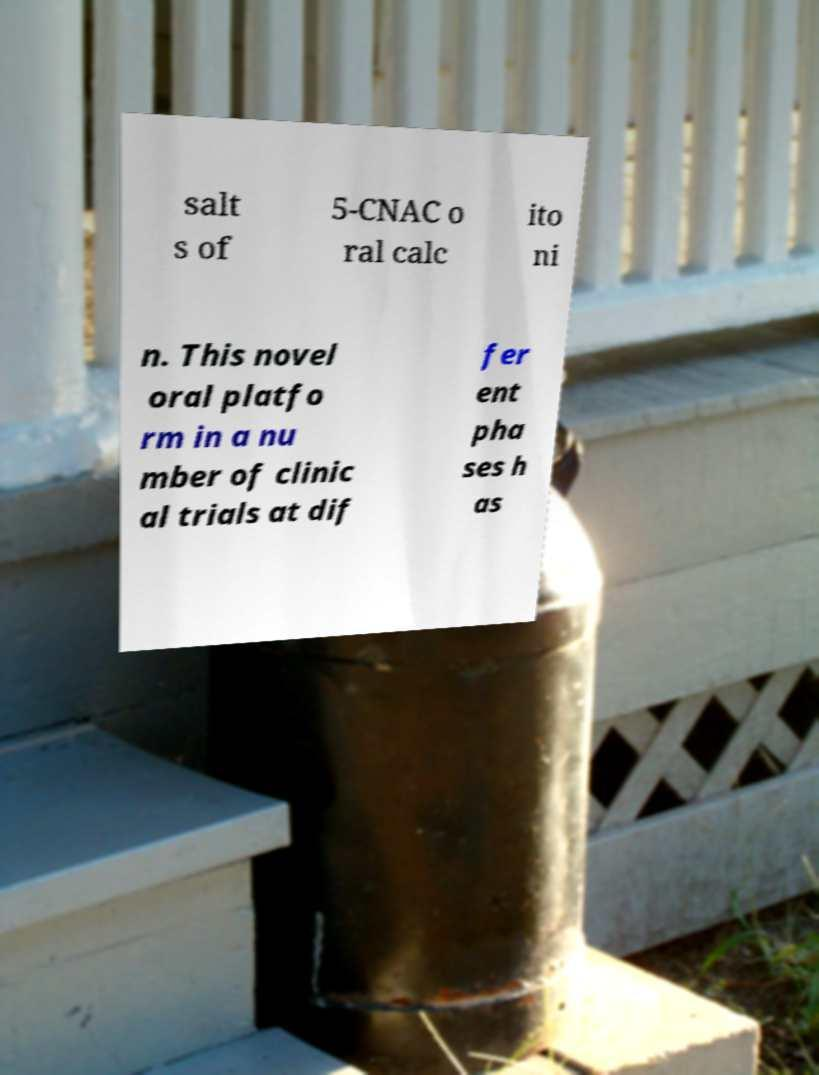There's text embedded in this image that I need extracted. Can you transcribe it verbatim? salt s of 5-CNAC o ral calc ito ni n. This novel oral platfo rm in a nu mber of clinic al trials at dif fer ent pha ses h as 